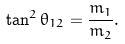Convert formula to latex. <formula><loc_0><loc_0><loc_500><loc_500>\tan ^ { 2 } \theta _ { 1 2 } = \frac { m _ { 1 } } { m _ { 2 } } .</formula> 